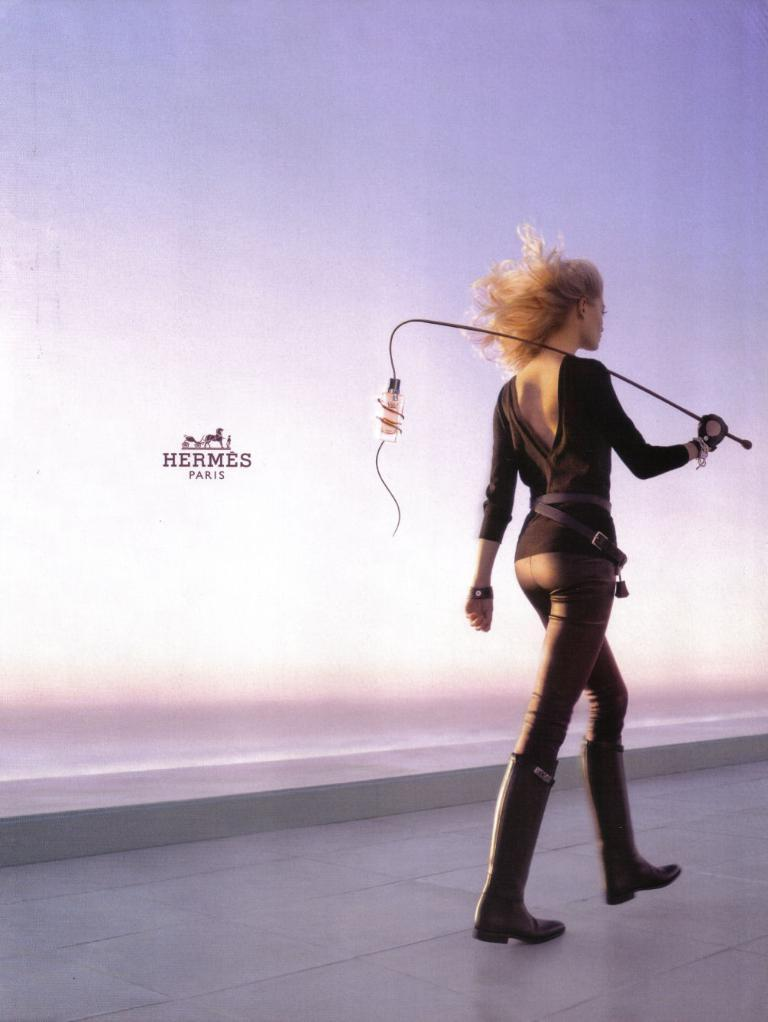Who is the main subject in the picture? There is a girl in the picture. What is the girl wearing? The girl is wearing a black t-shirt, black jeans, and black boots. What is the girl holding in her hand? The girl is holding a stick in her hand. Can you see a frog wearing a veil in the picture? No, there is no frog or veil present in the image. What type of sponge is the girl using to clean the stick? There is no sponge visible in the image, and the girl is not cleaning the stick. 